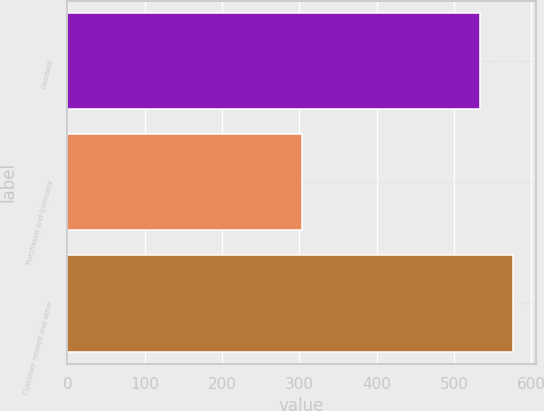<chart> <loc_0><loc_0><loc_500><loc_500><bar_chart><fcel>Goodwill<fcel>Purchased and internally<fcel>Customer related and other<nl><fcel>534.3<fcel>303<fcel>576.9<nl></chart> 